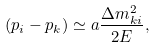Convert formula to latex. <formula><loc_0><loc_0><loc_500><loc_500>( p _ { i } - p _ { k } ) \simeq a \frac { \Delta m _ { k i } ^ { 2 } } { 2 E } ,</formula> 